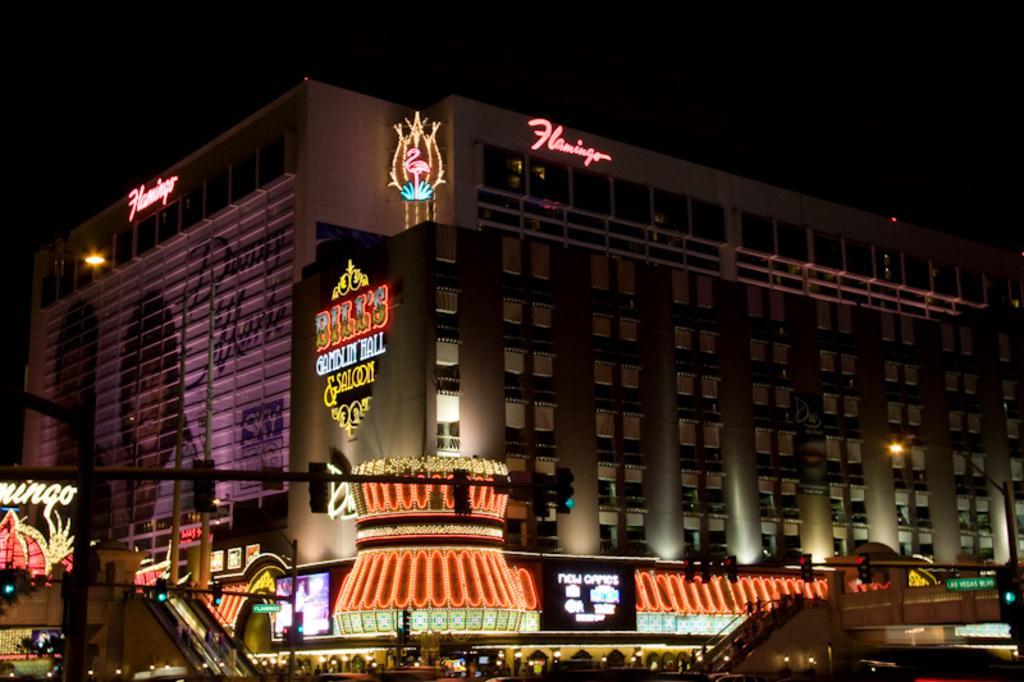Please provide a concise description of this image. This is clicked at night time, there is building in the back with lights on it, in the front there are stores and buildings with colorful lights all over it. 